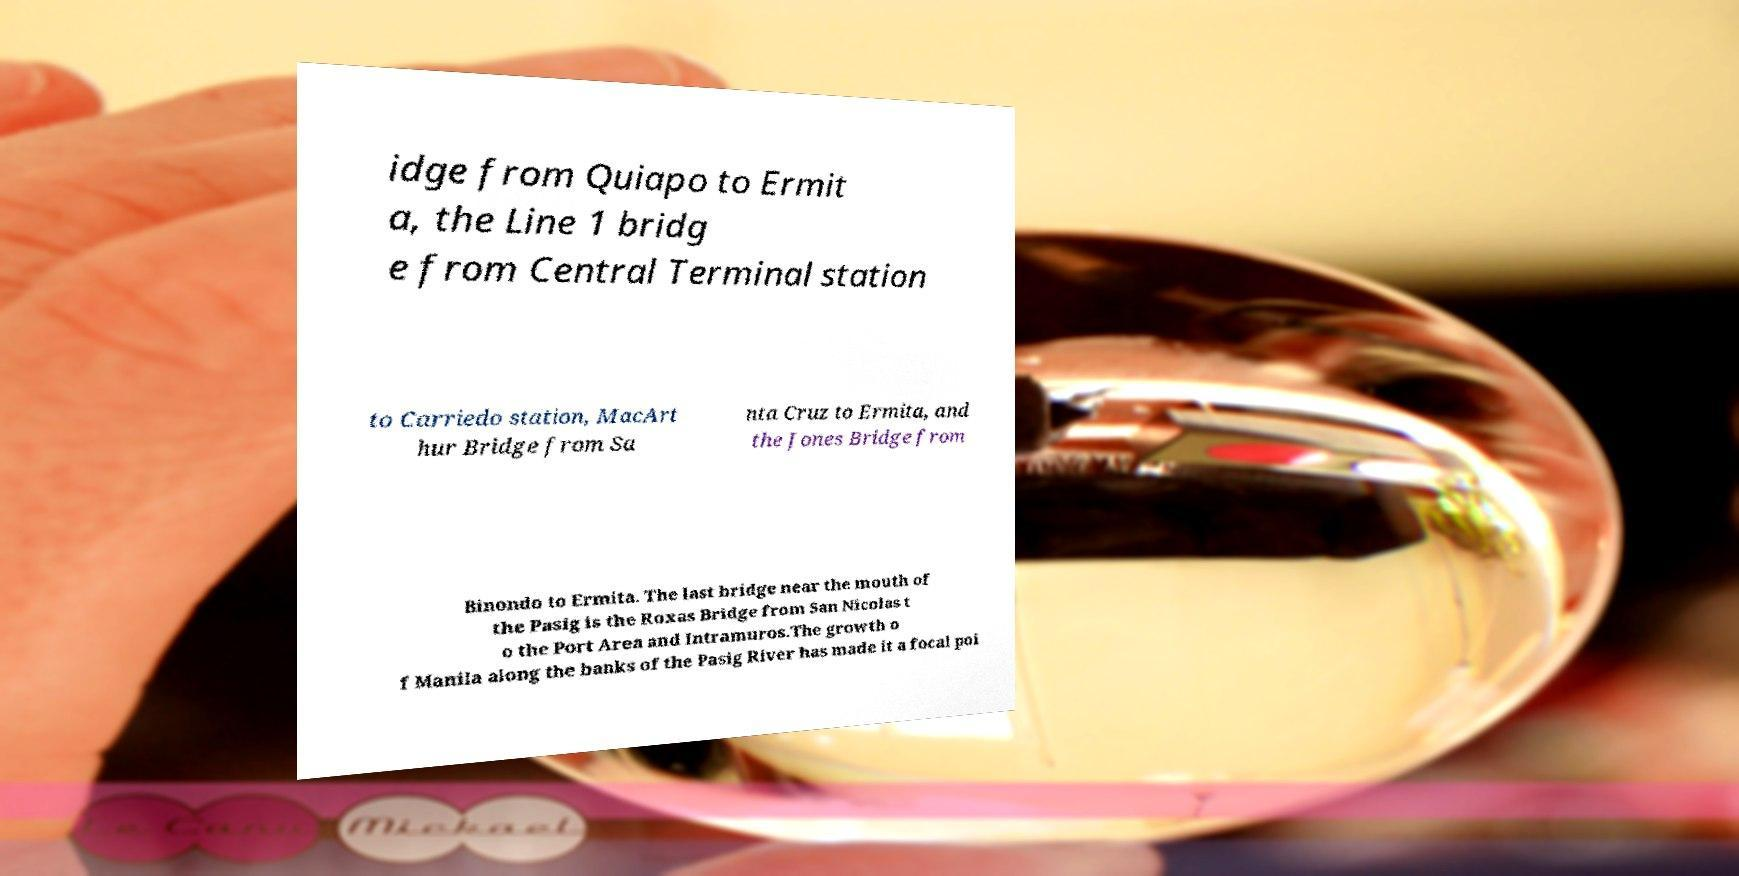There's text embedded in this image that I need extracted. Can you transcribe it verbatim? idge from Quiapo to Ermit a, the Line 1 bridg e from Central Terminal station to Carriedo station, MacArt hur Bridge from Sa nta Cruz to Ermita, and the Jones Bridge from Binondo to Ermita. The last bridge near the mouth of the Pasig is the Roxas Bridge from San Nicolas t o the Port Area and Intramuros.The growth o f Manila along the banks of the Pasig River has made it a focal poi 